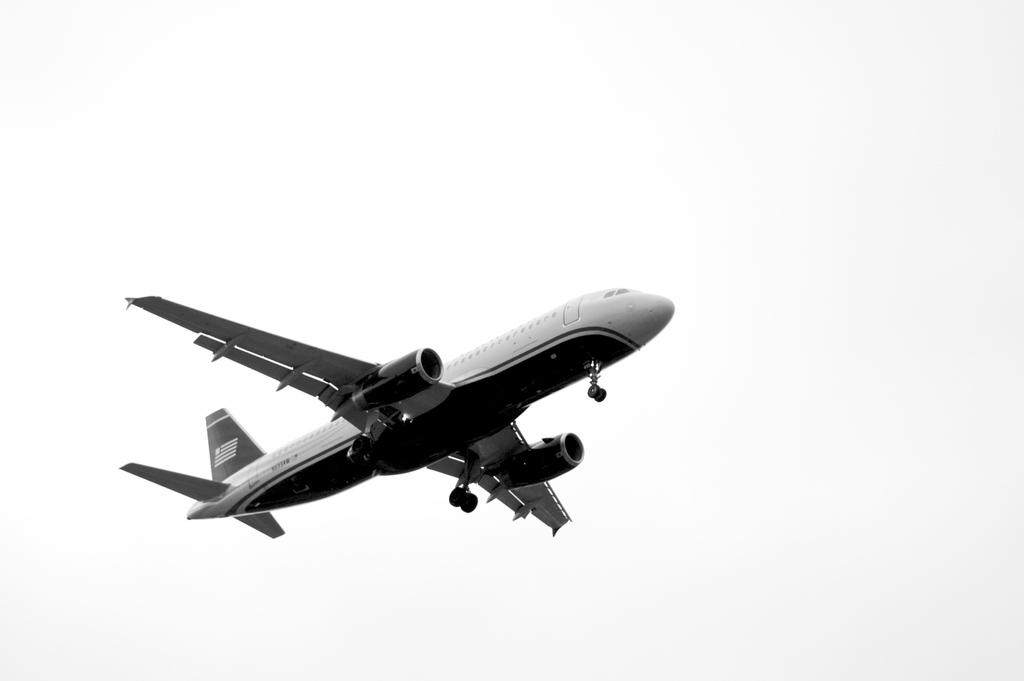What is the main subject of the image? The main subject of the image is an airplane. Where is the airplane located in the image? The airplane is in the center of the image. What is the setting of the image? The airplane is in the sky. What type of soda is being served on the airplane in the image? There is no indication of any soda or beverage service in the image, as it only features an airplane in the sky. 